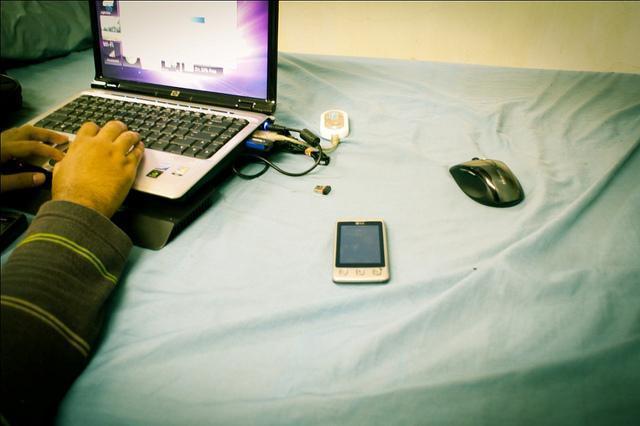How many people are visible?
Give a very brief answer. 1. How many clocks in this photo?
Give a very brief answer. 0. 